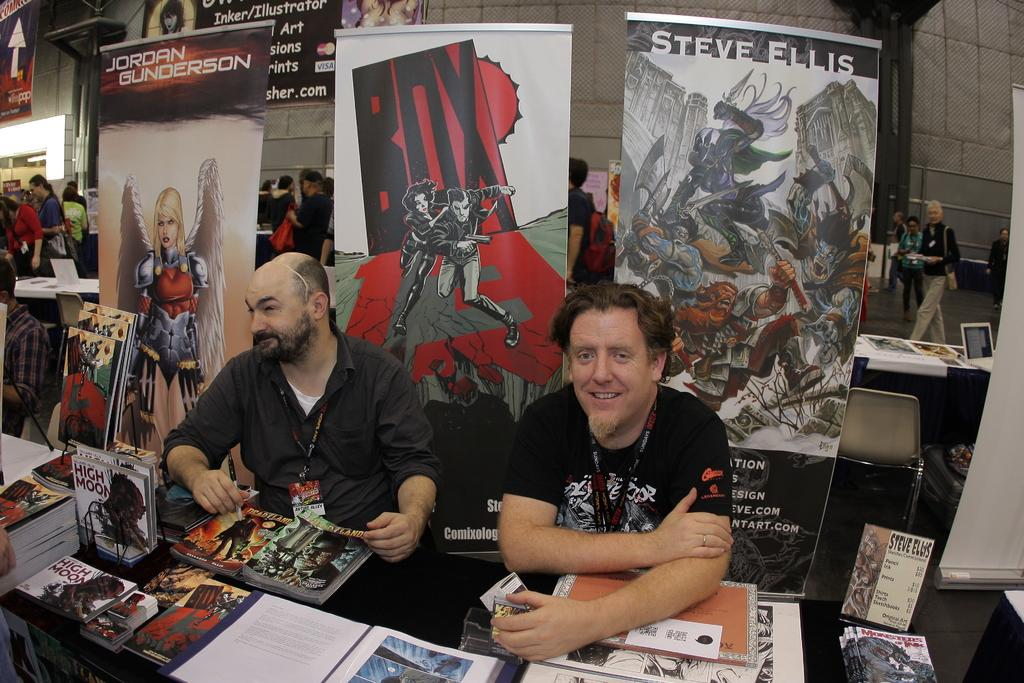<image>
Present a compact description of the photo's key features. TWO MEN SITTING DOWN AT A TABLE AT A CONVENTION WITH 3 BANNERS BEHIND THEM, ONE OF WHICH SAYS STEVE ELLIS 